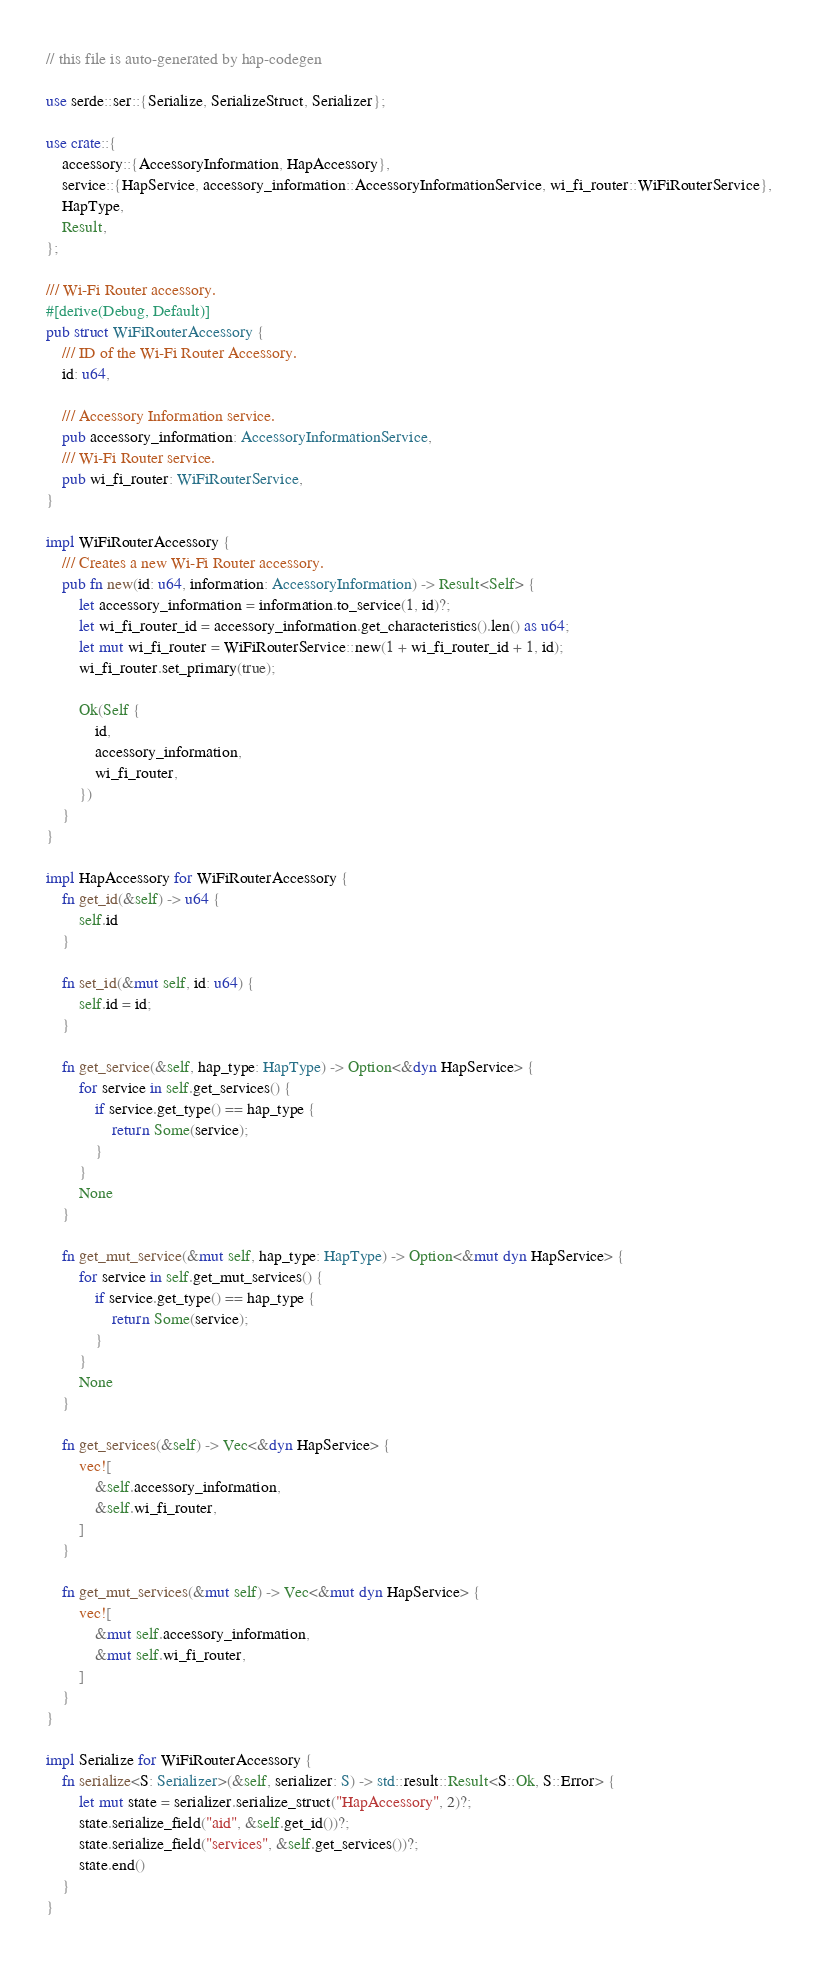<code> <loc_0><loc_0><loc_500><loc_500><_Rust_>// this file is auto-generated by hap-codegen

use serde::ser::{Serialize, SerializeStruct, Serializer};

use crate::{
	accessory::{AccessoryInformation, HapAccessory},
	service::{HapService, accessory_information::AccessoryInformationService, wi_fi_router::WiFiRouterService},
	HapType,
	Result,
};

/// Wi-Fi Router accessory.
#[derive(Debug, Default)]
pub struct WiFiRouterAccessory {
    /// ID of the Wi-Fi Router Accessory.
    id: u64,

    /// Accessory Information service.
    pub accessory_information: AccessoryInformationService,
    /// Wi-Fi Router service.
    pub wi_fi_router: WiFiRouterService,
}

impl WiFiRouterAccessory {
    /// Creates a new Wi-Fi Router accessory.
    pub fn new(id: u64, information: AccessoryInformation) -> Result<Self> {
        let accessory_information = information.to_service(1, id)?;
        let wi_fi_router_id = accessory_information.get_characteristics().len() as u64;
        let mut wi_fi_router = WiFiRouterService::new(1 + wi_fi_router_id + 1, id);
        wi_fi_router.set_primary(true);

        Ok(Self {
            id,
            accessory_information,
            wi_fi_router,
        })
    }
}

impl HapAccessory for WiFiRouterAccessory {
    fn get_id(&self) -> u64 {
        self.id
    }

    fn set_id(&mut self, id: u64) {
        self.id = id;
    }

    fn get_service(&self, hap_type: HapType) -> Option<&dyn HapService> {
        for service in self.get_services() {
            if service.get_type() == hap_type {
                return Some(service);
            }
        }
        None
    }

    fn get_mut_service(&mut self, hap_type: HapType) -> Option<&mut dyn HapService> {
        for service in self.get_mut_services() {
            if service.get_type() == hap_type {
                return Some(service);
            }
        }
        None
    }

    fn get_services(&self) -> Vec<&dyn HapService> {
        vec![
            &self.accessory_information,
            &self.wi_fi_router,
        ]
    }

    fn get_mut_services(&mut self) -> Vec<&mut dyn HapService> {
        vec![
            &mut self.accessory_information,
            &mut self.wi_fi_router,
        ]
    }
}

impl Serialize for WiFiRouterAccessory {
    fn serialize<S: Serializer>(&self, serializer: S) -> std::result::Result<S::Ok, S::Error> {
        let mut state = serializer.serialize_struct("HapAccessory", 2)?;
        state.serialize_field("aid", &self.get_id())?;
        state.serialize_field("services", &self.get_services())?;
        state.end()
    }
}
</code> 